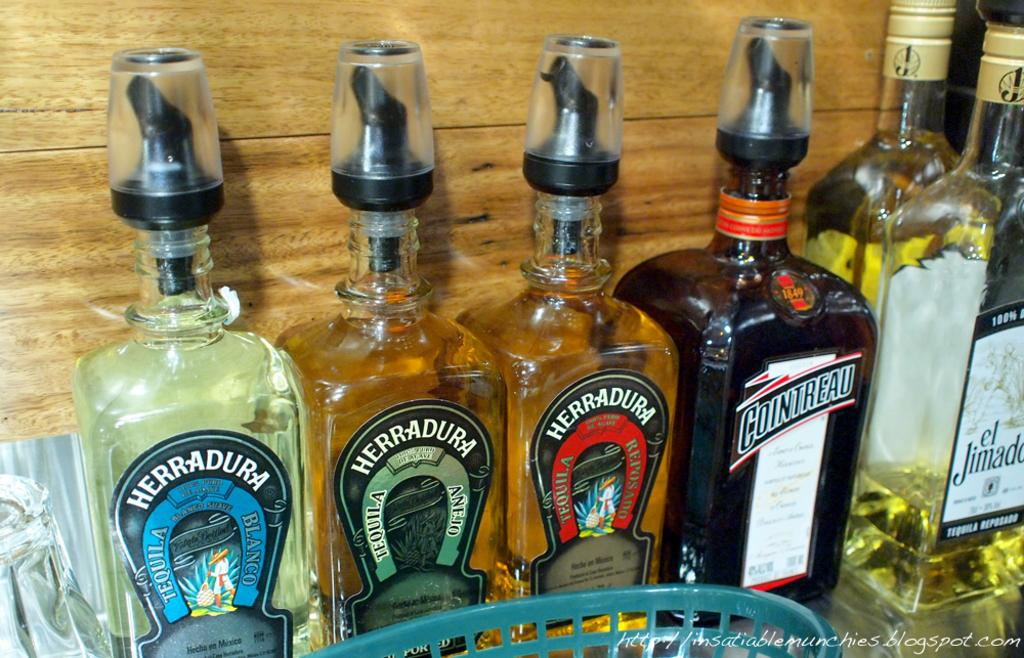What type of table is in the image? There is a wooden table in the image. What is on the wooden table? Six wine bottles are present on the table. Is there any other object on the table besides the wine bottles? Yes, there is a basket on the table. How is the payment for the wine bottles being processed in the image? There is no indication of payment processing in the image; it only shows a wooden table with six wine bottles and a basket. 